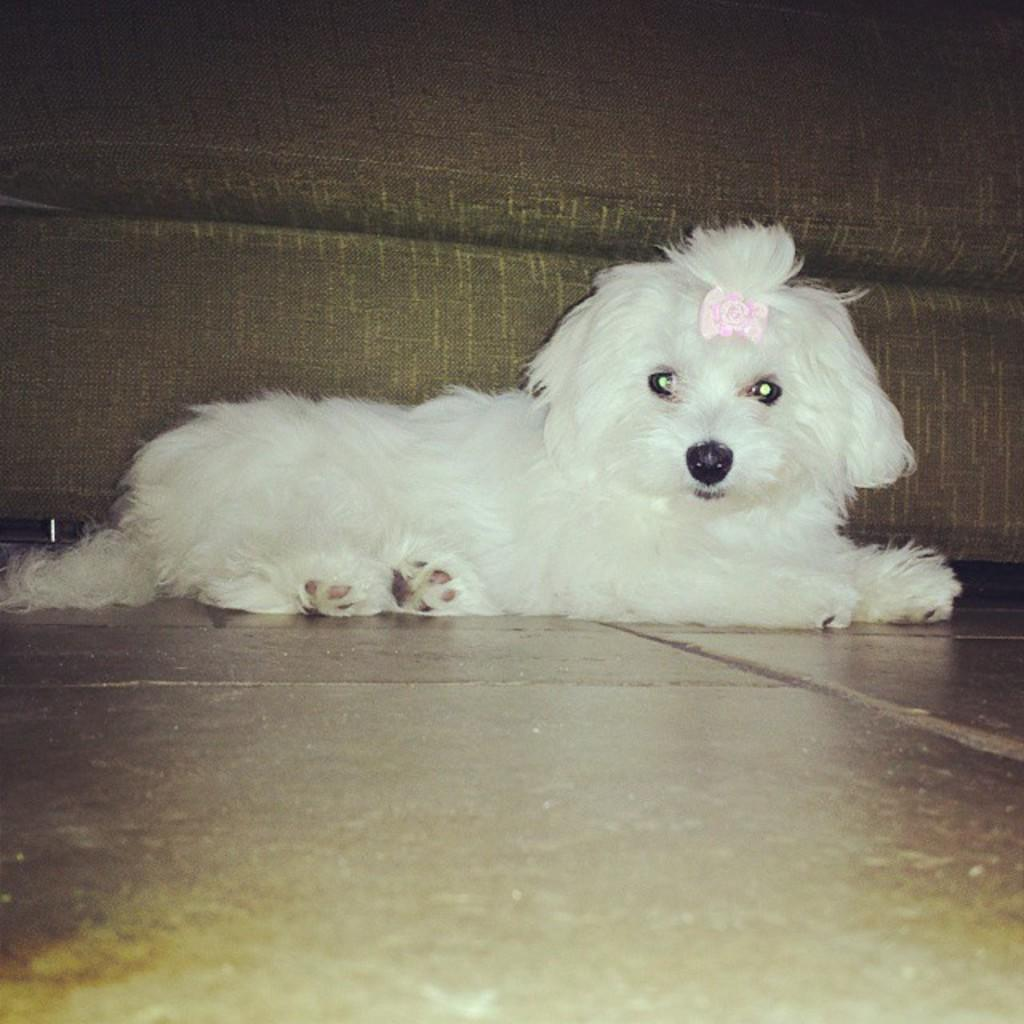What type of animal is in the image? There is a white dog in the image. Where is the dog located in the image? The dog is sitting on the floor. What type of joke is the dog telling in the image? There is no indication in the image that the dog is telling a joke, as dogs do not have the ability to communicate through jokes. 